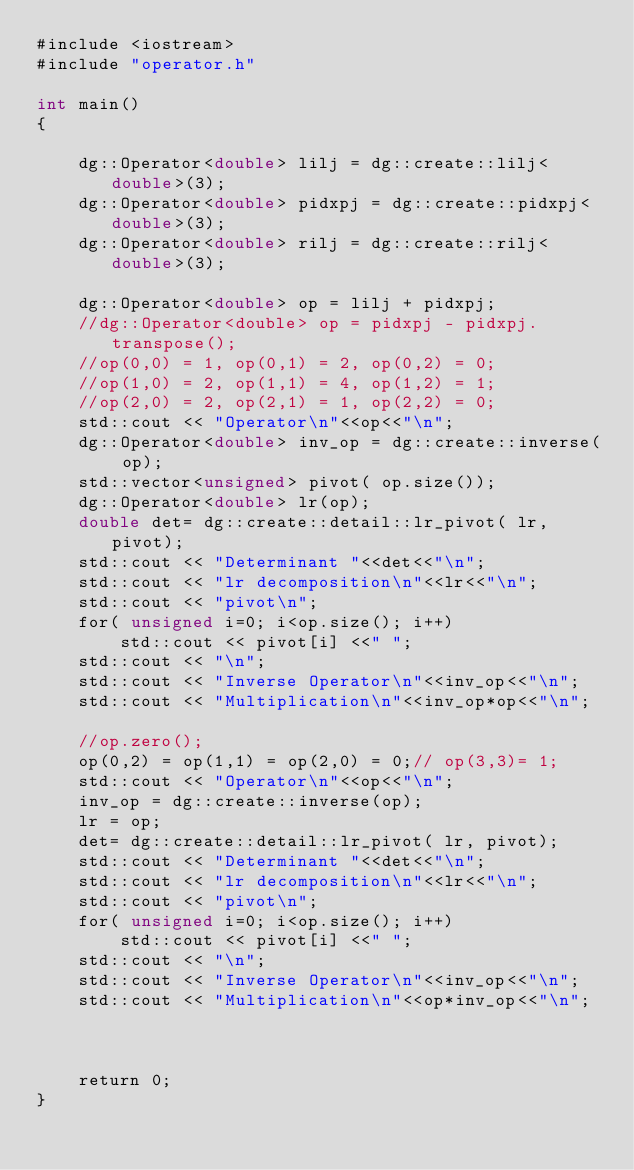<code> <loc_0><loc_0><loc_500><loc_500><_Cuda_>#include <iostream>
#include "operator.h"

int main()
{

    dg::Operator<double> lilj = dg::create::lilj<double>(3);
    dg::Operator<double> pidxpj = dg::create::pidxpj<double>(3);
    dg::Operator<double> rilj = dg::create::rilj<double>(3);

    dg::Operator<double> op = lilj + pidxpj;
    //dg::Operator<double> op = pidxpj - pidxpj.transpose();
    //op(0,0) = 1, op(0,1) = 2, op(0,2) = 0;
    //op(1,0) = 2, op(1,1) = 4, op(1,2) = 1;
    //op(2,0) = 2, op(2,1) = 1, op(2,2) = 0;
    std::cout << "Operator\n"<<op<<"\n";
    dg::Operator<double> inv_op = dg::create::inverse( op);
    std::vector<unsigned> pivot( op.size());
    dg::Operator<double> lr(op);
    double det= dg::create::detail::lr_pivot( lr, pivot);
    std::cout << "Determinant "<<det<<"\n";
    std::cout << "lr decomposition\n"<<lr<<"\n";
    std::cout << "pivot\n";
    for( unsigned i=0; i<op.size(); i++)
        std::cout << pivot[i] <<" ";
    std::cout << "\n";
    std::cout << "Inverse Operator\n"<<inv_op<<"\n";
    std::cout << "Multiplication\n"<<inv_op*op<<"\n";

    //op.zero();
    op(0,2) = op(1,1) = op(2,0) = 0;// op(3,3)= 1;
    std::cout << "Operator\n"<<op<<"\n";
    inv_op = dg::create::inverse(op);
    lr = op;
    det= dg::create::detail::lr_pivot( lr, pivot);
    std::cout << "Determinant "<<det<<"\n";
    std::cout << "lr decomposition\n"<<lr<<"\n";
    std::cout << "pivot\n";
    for( unsigned i=0; i<op.size(); i++)
        std::cout << pivot[i] <<" ";
    std::cout << "\n";
    std::cout << "Inverse Operator\n"<<inv_op<<"\n";
    std::cout << "Multiplication\n"<<op*inv_op<<"\n";



    return 0;
}
</code> 